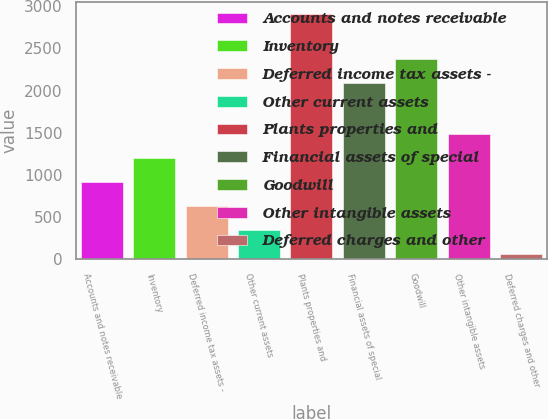<chart> <loc_0><loc_0><loc_500><loc_500><bar_chart><fcel>Accounts and notes receivable<fcel>Inventory<fcel>Deferred income tax assets -<fcel>Other current assets<fcel>Plants properties and<fcel>Financial assets of special<fcel>Goodwill<fcel>Other intangible assets<fcel>Deferred charges and other<nl><fcel>911.1<fcel>1196.8<fcel>625.4<fcel>339.7<fcel>2911<fcel>2091<fcel>2376.7<fcel>1482.5<fcel>54<nl></chart> 